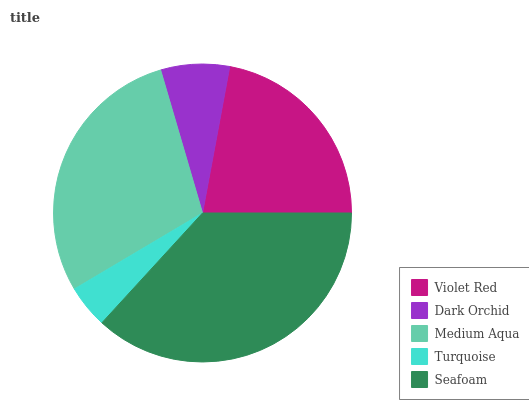Is Turquoise the minimum?
Answer yes or no. Yes. Is Seafoam the maximum?
Answer yes or no. Yes. Is Dark Orchid the minimum?
Answer yes or no. No. Is Dark Orchid the maximum?
Answer yes or no. No. Is Violet Red greater than Dark Orchid?
Answer yes or no. Yes. Is Dark Orchid less than Violet Red?
Answer yes or no. Yes. Is Dark Orchid greater than Violet Red?
Answer yes or no. No. Is Violet Red less than Dark Orchid?
Answer yes or no. No. Is Violet Red the high median?
Answer yes or no. Yes. Is Violet Red the low median?
Answer yes or no. Yes. Is Medium Aqua the high median?
Answer yes or no. No. Is Turquoise the low median?
Answer yes or no. No. 